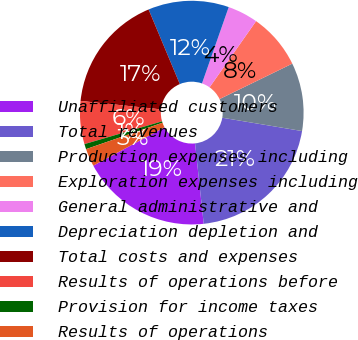Convert chart to OTSL. <chart><loc_0><loc_0><loc_500><loc_500><pie_chart><fcel>Unaffiliated customers<fcel>Total revenues<fcel>Production expenses including<fcel>Exploration expenses including<fcel>General administrative and<fcel>Depreciation depletion and<fcel>Total costs and expenses<fcel>Results of operations before<fcel>Provision for income taxes<fcel>Results of operations<nl><fcel>18.84%<fcel>20.66%<fcel>9.85%<fcel>8.03%<fcel>4.39%<fcel>11.67%<fcel>17.02%<fcel>6.21%<fcel>0.75%<fcel>2.57%<nl></chart> 